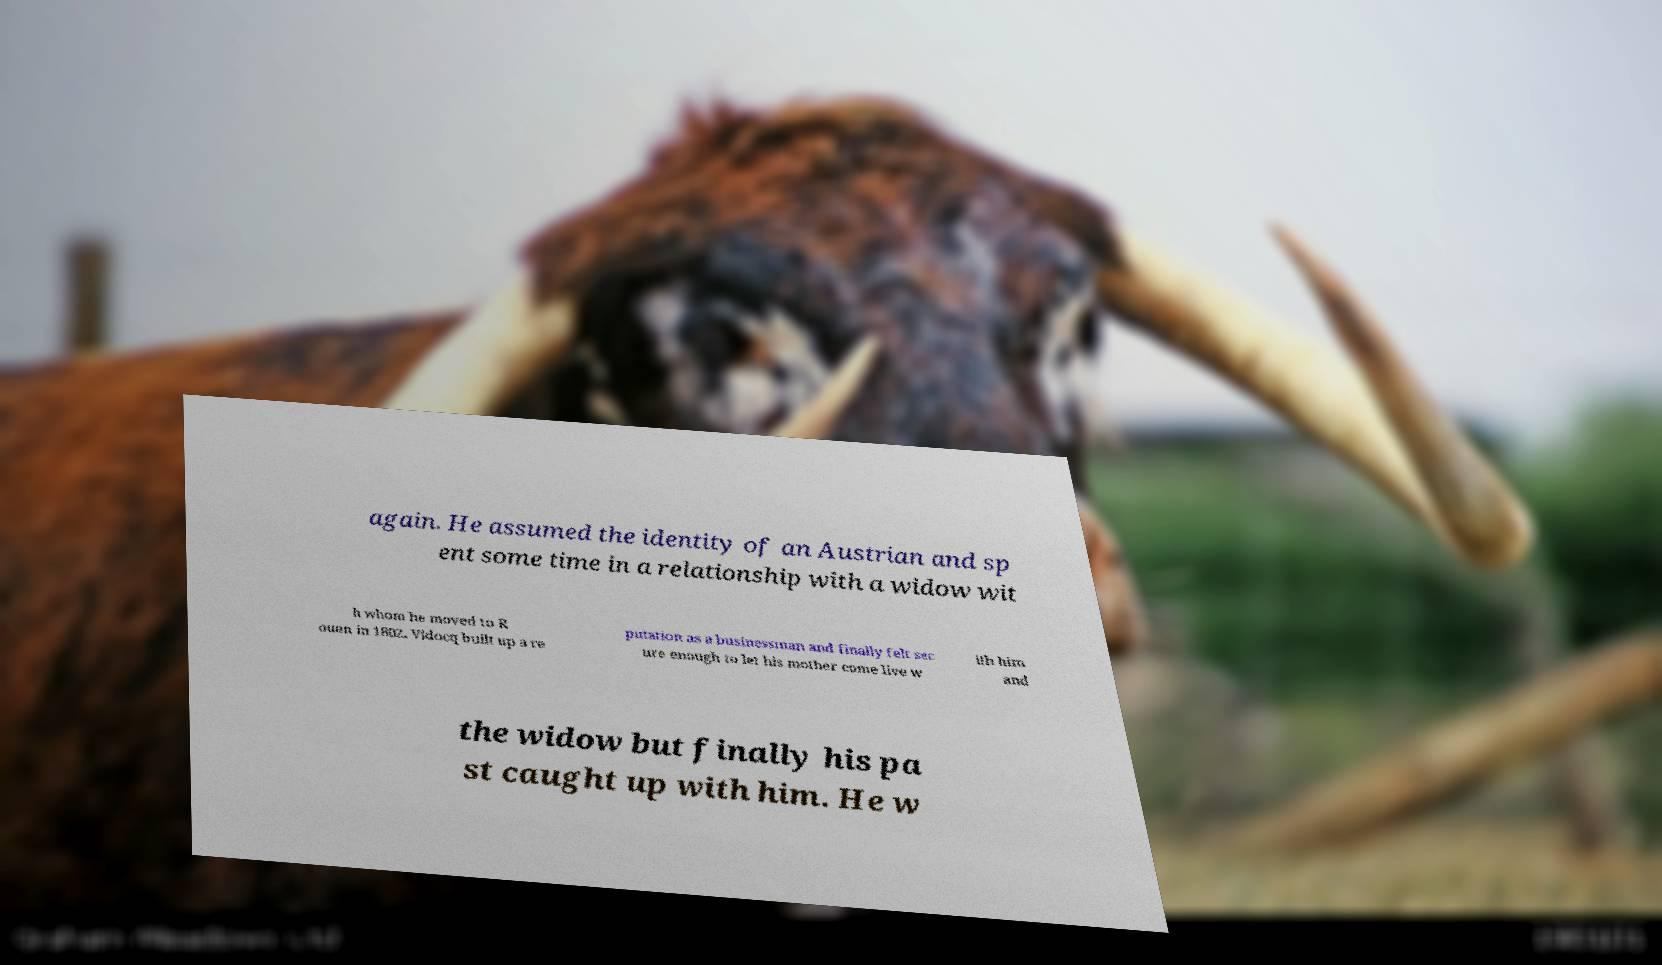Please read and relay the text visible in this image. What does it say? again. He assumed the identity of an Austrian and sp ent some time in a relationship with a widow wit h whom he moved to R ouen in 1802. Vidocq built up a re putation as a businessman and finally felt sec ure enough to let his mother come live w ith him and the widow but finally his pa st caught up with him. He w 